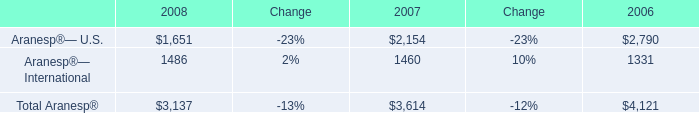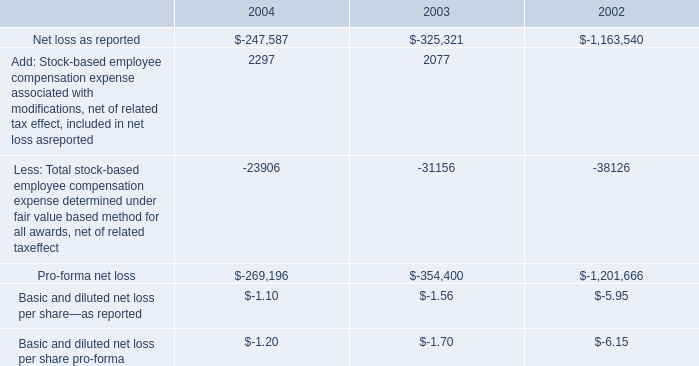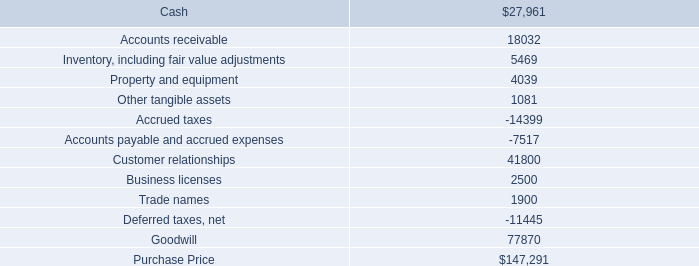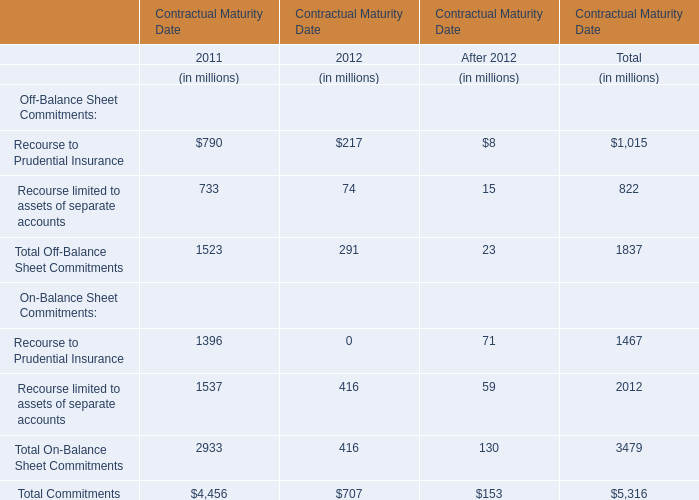what is the percentage change in 401 ( k ) contributed amounts from 2003 to 2004? 
Computations: ((533000 - 825000) / 825000)
Answer: -0.35394. 